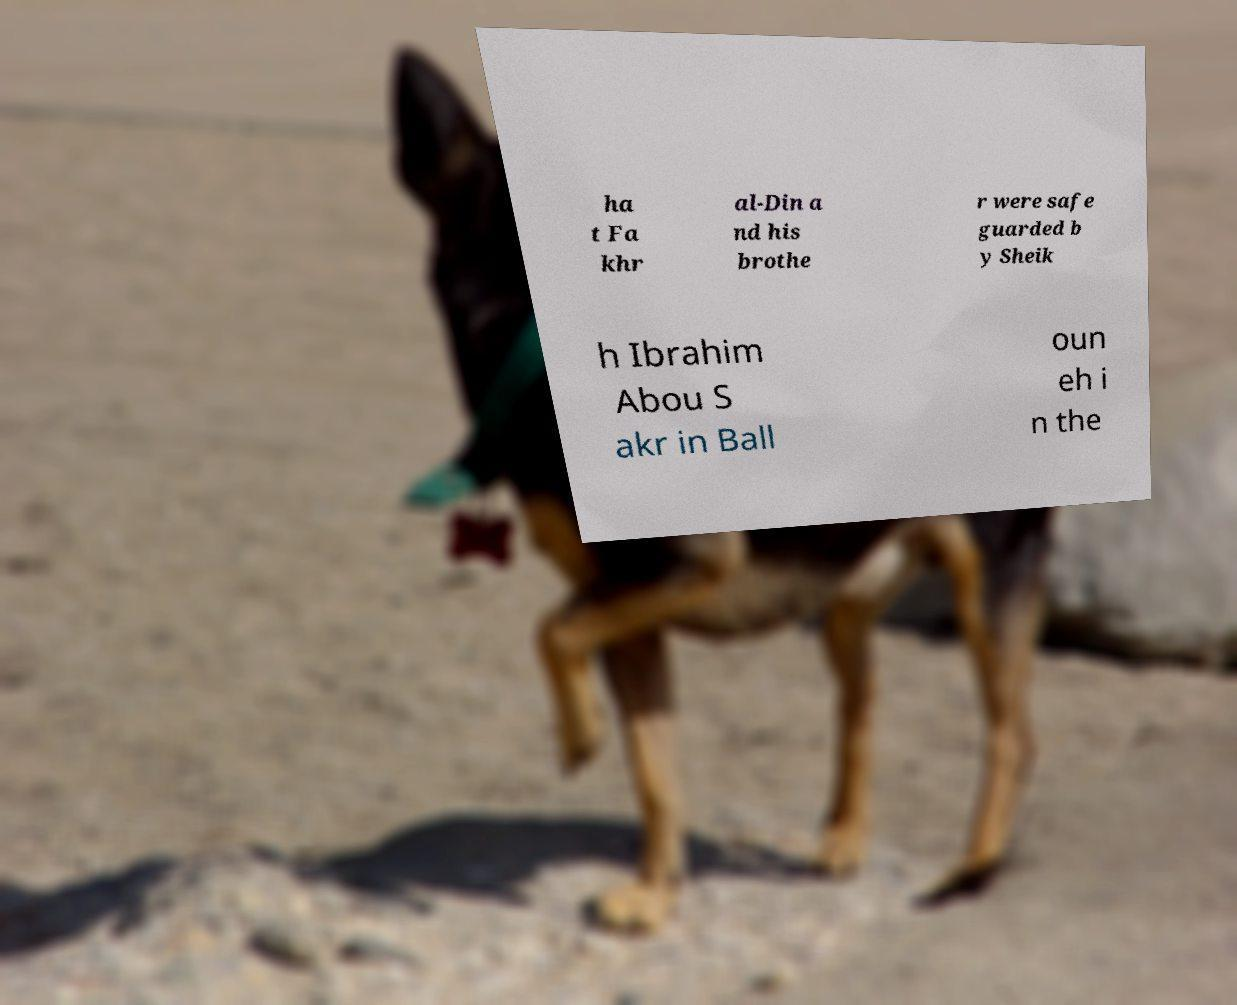Could you assist in decoding the text presented in this image and type it out clearly? ha t Fa khr al-Din a nd his brothe r were safe guarded b y Sheik h Ibrahim Abou S akr in Ball oun eh i n the 